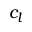Convert formula to latex. <formula><loc_0><loc_0><loc_500><loc_500>c _ { l }</formula> 